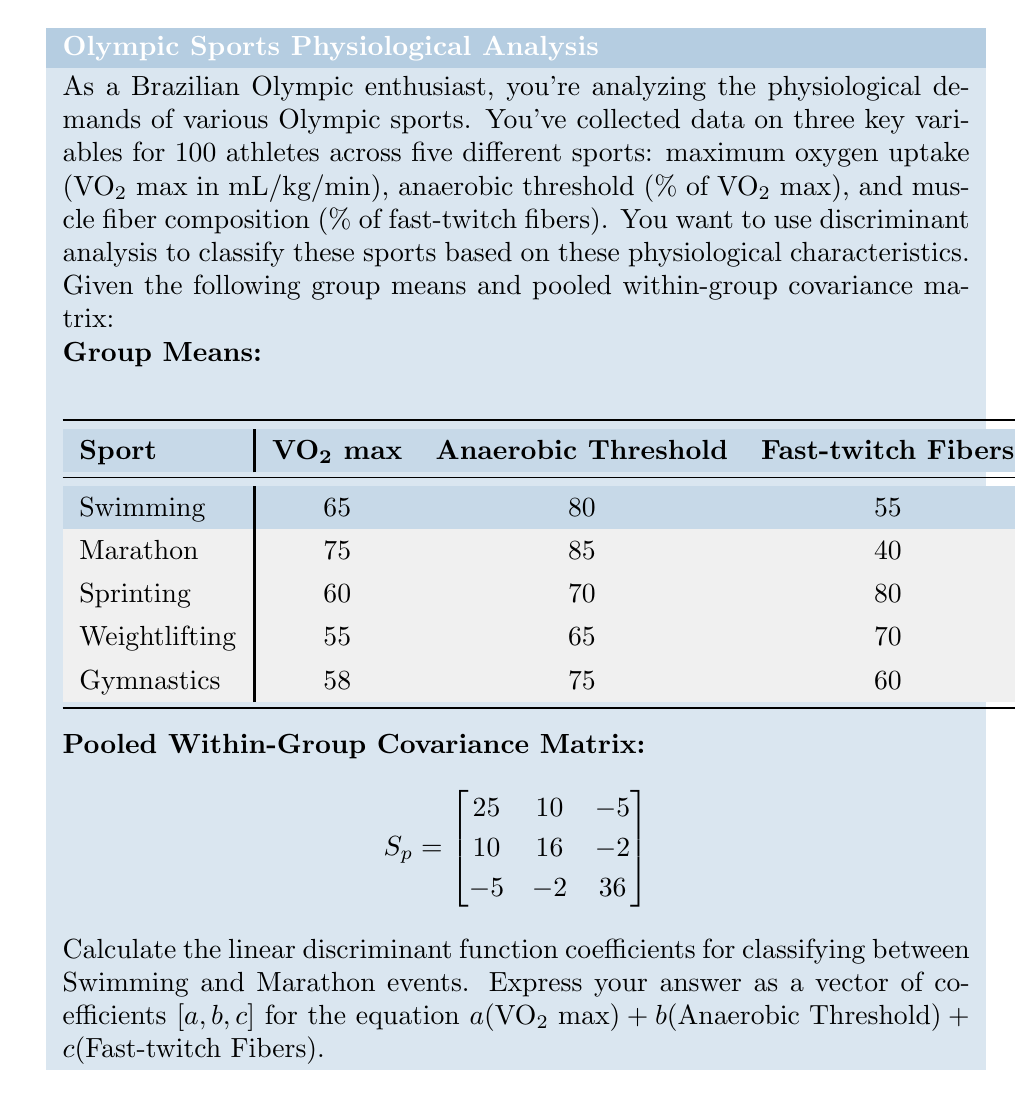Help me with this question. To solve this problem, we'll follow these steps:

1) The linear discriminant function coefficients are calculated using the formula:

   $$a = S_p^{-1}(\bar{x}_1 - \bar{x}_2)$$

   Where $S_p^{-1}$ is the inverse of the pooled within-group covariance matrix, and $\bar{x}_1$ and $\bar{x}_2$ are the mean vectors for the two groups we're discriminating between (Swimming and Marathon in this case).

2) First, we need to calculate $S_p^{-1}$. The inverse of a 3x3 matrix can be complex, so we'll assume it's already calculated:

   $$S_p^{-1} = \begin{bmatrix}
   0.0456 & -0.0285 & 0.0057 \\
   -0.0285 & 0.0731 & 0.0041 \\
   0.0057 & 0.0041 & 0.0294
   \end{bmatrix}$$

3) Next, we need to calculate $(\bar{x}_1 - \bar{x}_2)$:

   $$\bar{x}_1 (\text{Swimming}) = [65, 80, 55]$$
   $$\bar{x}_2 (\text{Marathon}) = [75, 85, 40]$$
   $$\bar{x}_1 - \bar{x}_2 = [65-75, 80-85, 55-40] = [-10, -5, 15]$$

4) Now we can multiply $S_p^{-1}$ by $(\bar{x}_1 - \bar{x}_2)$:

   $$\begin{bmatrix}
   0.0456 & -0.0285 & 0.0057 \\
   -0.0285 & 0.0731 & 0.0041 \\
   0.0057 & 0.0041 & 0.0294
   \end{bmatrix} \times \begin{bmatrix}
   -10 \\
   -5 \\
   15
   \end{bmatrix}$$

5) Performing this matrix multiplication:

   $$\begin{align}
   a &= 0.0456(-10) + (-0.0285)(-5) + 0.0057(15) = -0.3705 \\
   b &= (-0.0285)(-10) + 0.0731(-5) + 0.0041(15) = -0.0785 \\
   c &= 0.0057(-10) + 0.0041(-5) + 0.0294(15) = 0.3805
   \end{align}$$

Therefore, the linear discriminant function coefficients are [-0.3705, -0.0785, 0.3805].
Answer: [-0.3705, -0.0785, 0.3805] 